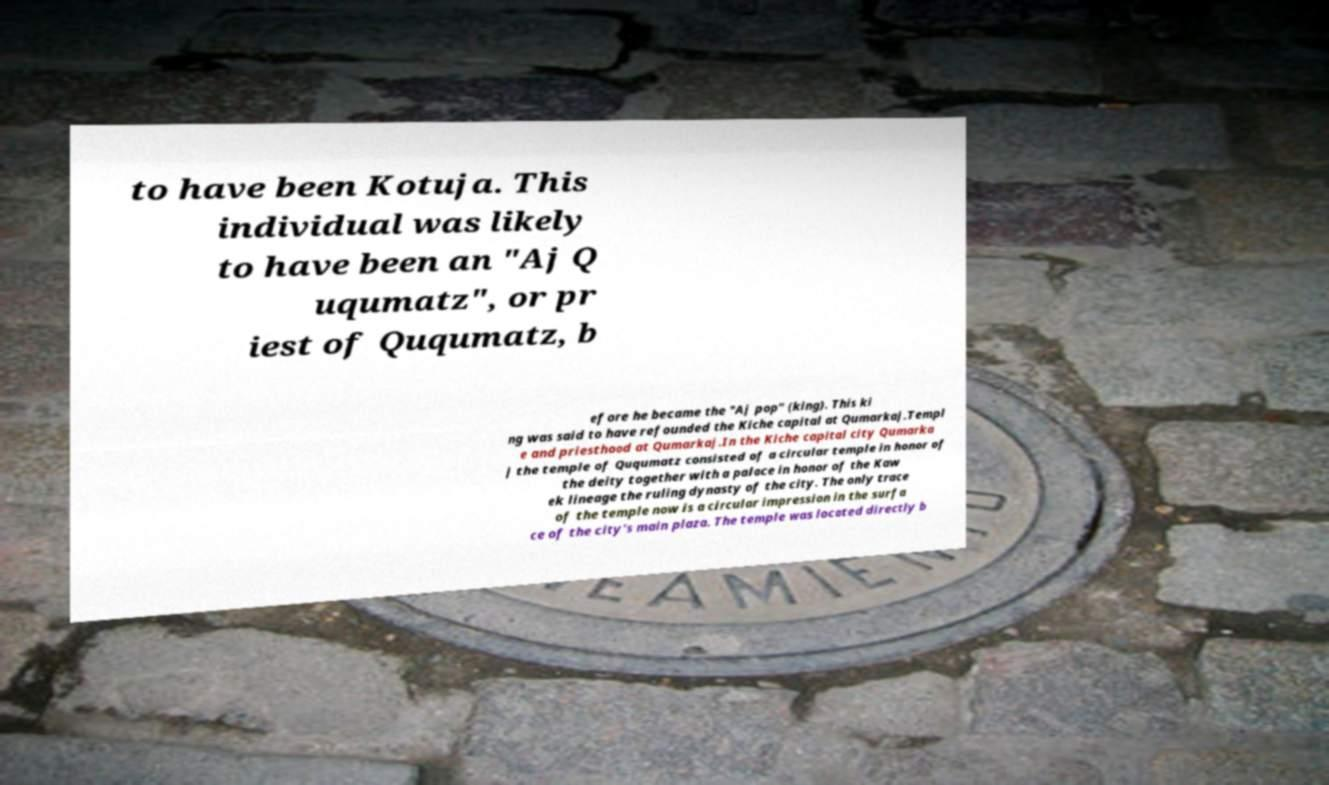I need the written content from this picture converted into text. Can you do that? to have been Kotuja. This individual was likely to have been an "Aj Q uqumatz", or pr iest of Ququmatz, b efore he became the "Aj pop" (king). This ki ng was said to have refounded the Kiche capital at Qumarkaj.Templ e and priesthood at Qumarkaj.In the Kiche capital city Qumarka j the temple of Ququmatz consisted of a circular temple in honor of the deity together with a palace in honor of the Kaw ek lineage the ruling dynasty of the city. The only trace of the temple now is a circular impression in the surfa ce of the city's main plaza. The temple was located directly b 